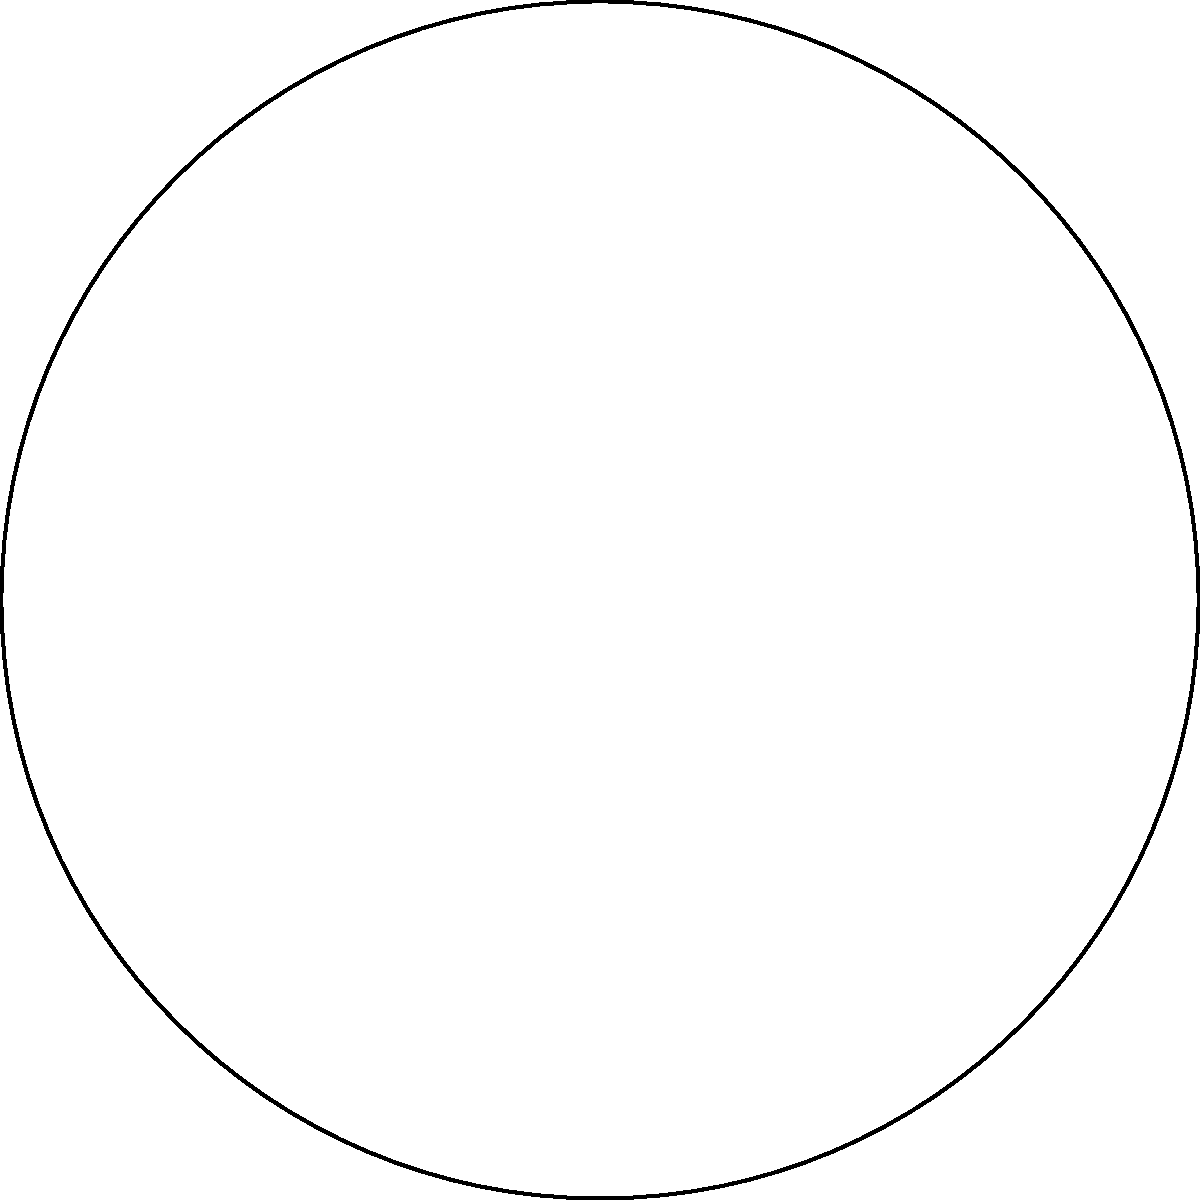As a mixologist, you're designing a circular bar top to showcase your finest spirits. The bar has a radius of 3 meters and you want to arrange 8 premium bottles equidistantly around its edge. What is the angle (in degrees) between any two adjacent bottles as seen from the center of the bar? Let's approach this step-by-step:

1) First, recall that a full circle contains 360°.

2) We need to divide this full circle into 8 equal parts, as we have 8 bottles to arrange.

3) To find the angle between any two adjacent bottles, we can use the formula:

   $$ \text{Angle} = \frac{\text{Total angle of the circle}}{\text{Number of bottles}} $$

4) Substituting our values:

   $$ \text{Angle} = \frac{360°}{8} $$

5) Performing the division:

   $$ \text{Angle} = 45° $$

6) We can verify this geometrically: 
   - In the diagram, angle AOB represents the angle between two adjacent bottles.
   - AOB forms an eighth of the full circle.
   - We know that an eighth of a circle is indeed 45°.

Therefore, the angle between any two adjacent bottles, as seen from the center of the bar, is 45°.
Answer: 45° 